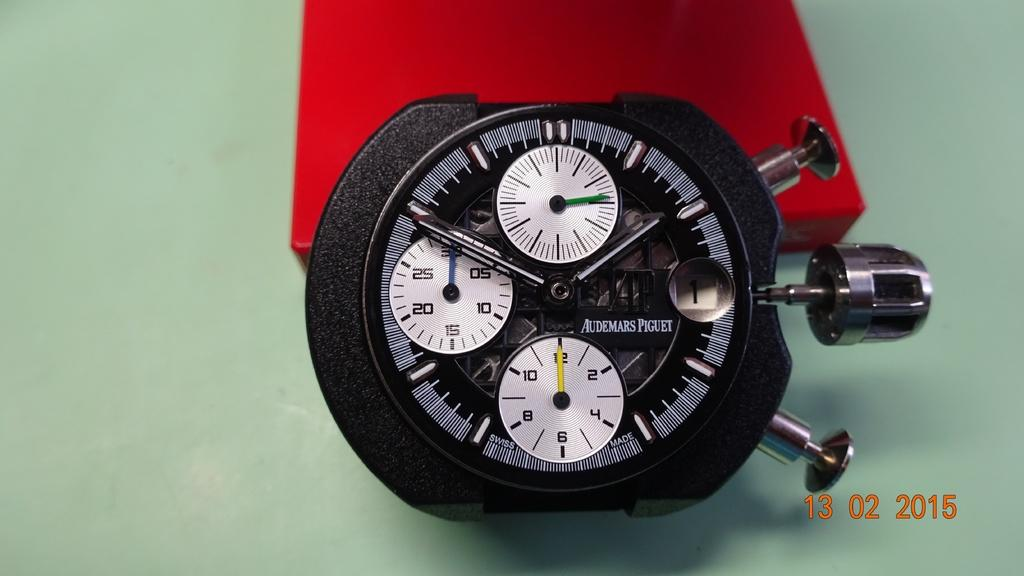<image>
Create a compact narrative representing the image presented. some clocks with the letter 13 next to it 